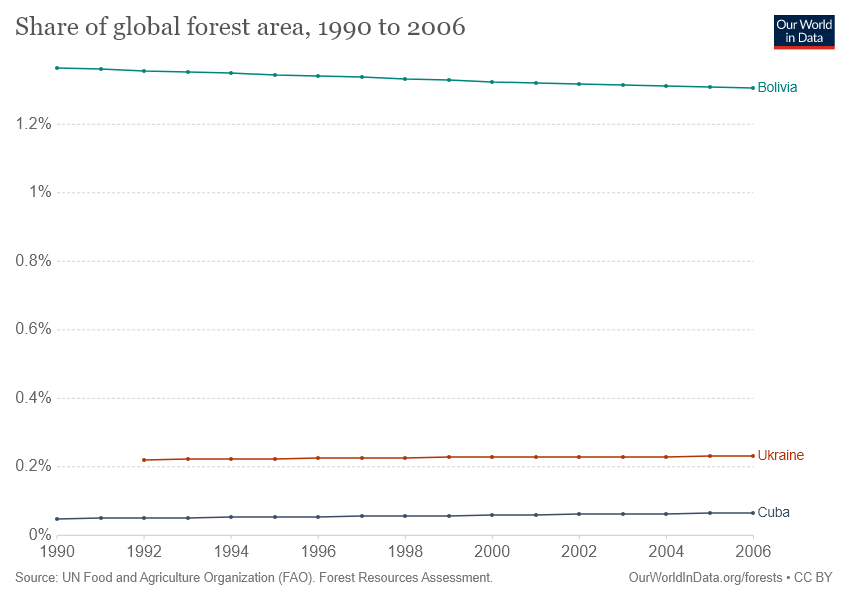Give some essential details in this illustration. Bolivia has the highest share of global forest area over the years, making it the country with the most forest coverage. A small number of countries hold a disproportionate amount of the world's forest cover, with some countries accounting for more than 0.2% of the global total. 